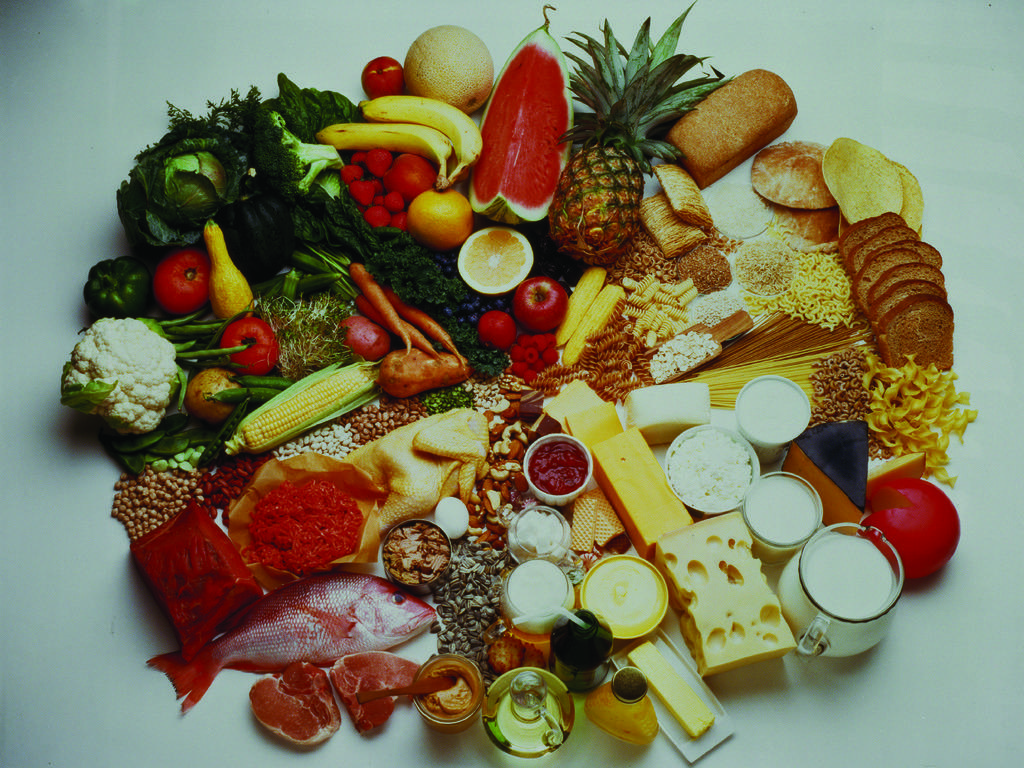What types of items can be seen in the image? There are food items in the image. On what surface are the food items placed? The food items are placed on a white surface. What is your aunt writing on the cover of the food items in the image? There is no mention of an aunt, writing, or cover in the image. The image only shows food items placed on a white surface. 